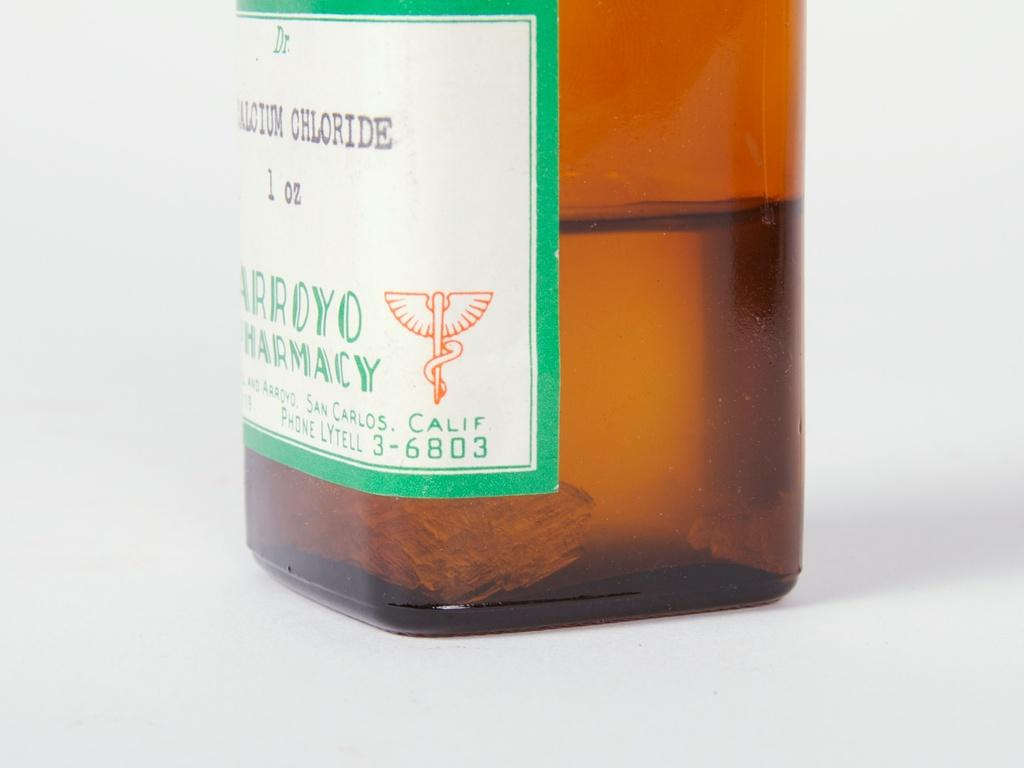<image>
Share a concise interpretation of the image provided. A brown bottle of calcium chloride sitting on a surface. 